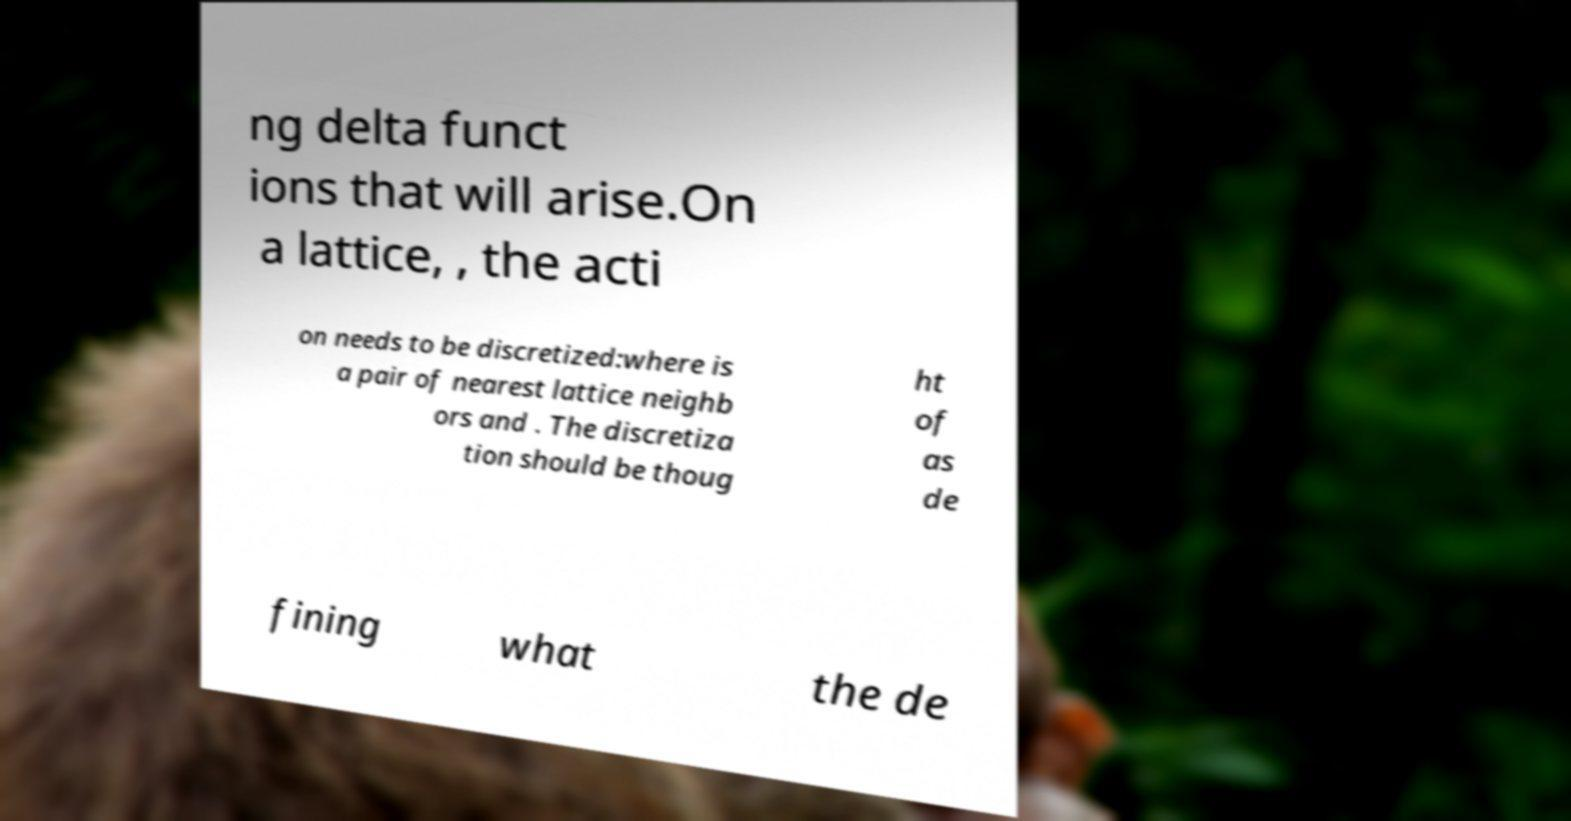For documentation purposes, I need the text within this image transcribed. Could you provide that? ng delta funct ions that will arise.On a lattice, , the acti on needs to be discretized:where is a pair of nearest lattice neighb ors and . The discretiza tion should be thoug ht of as de fining what the de 